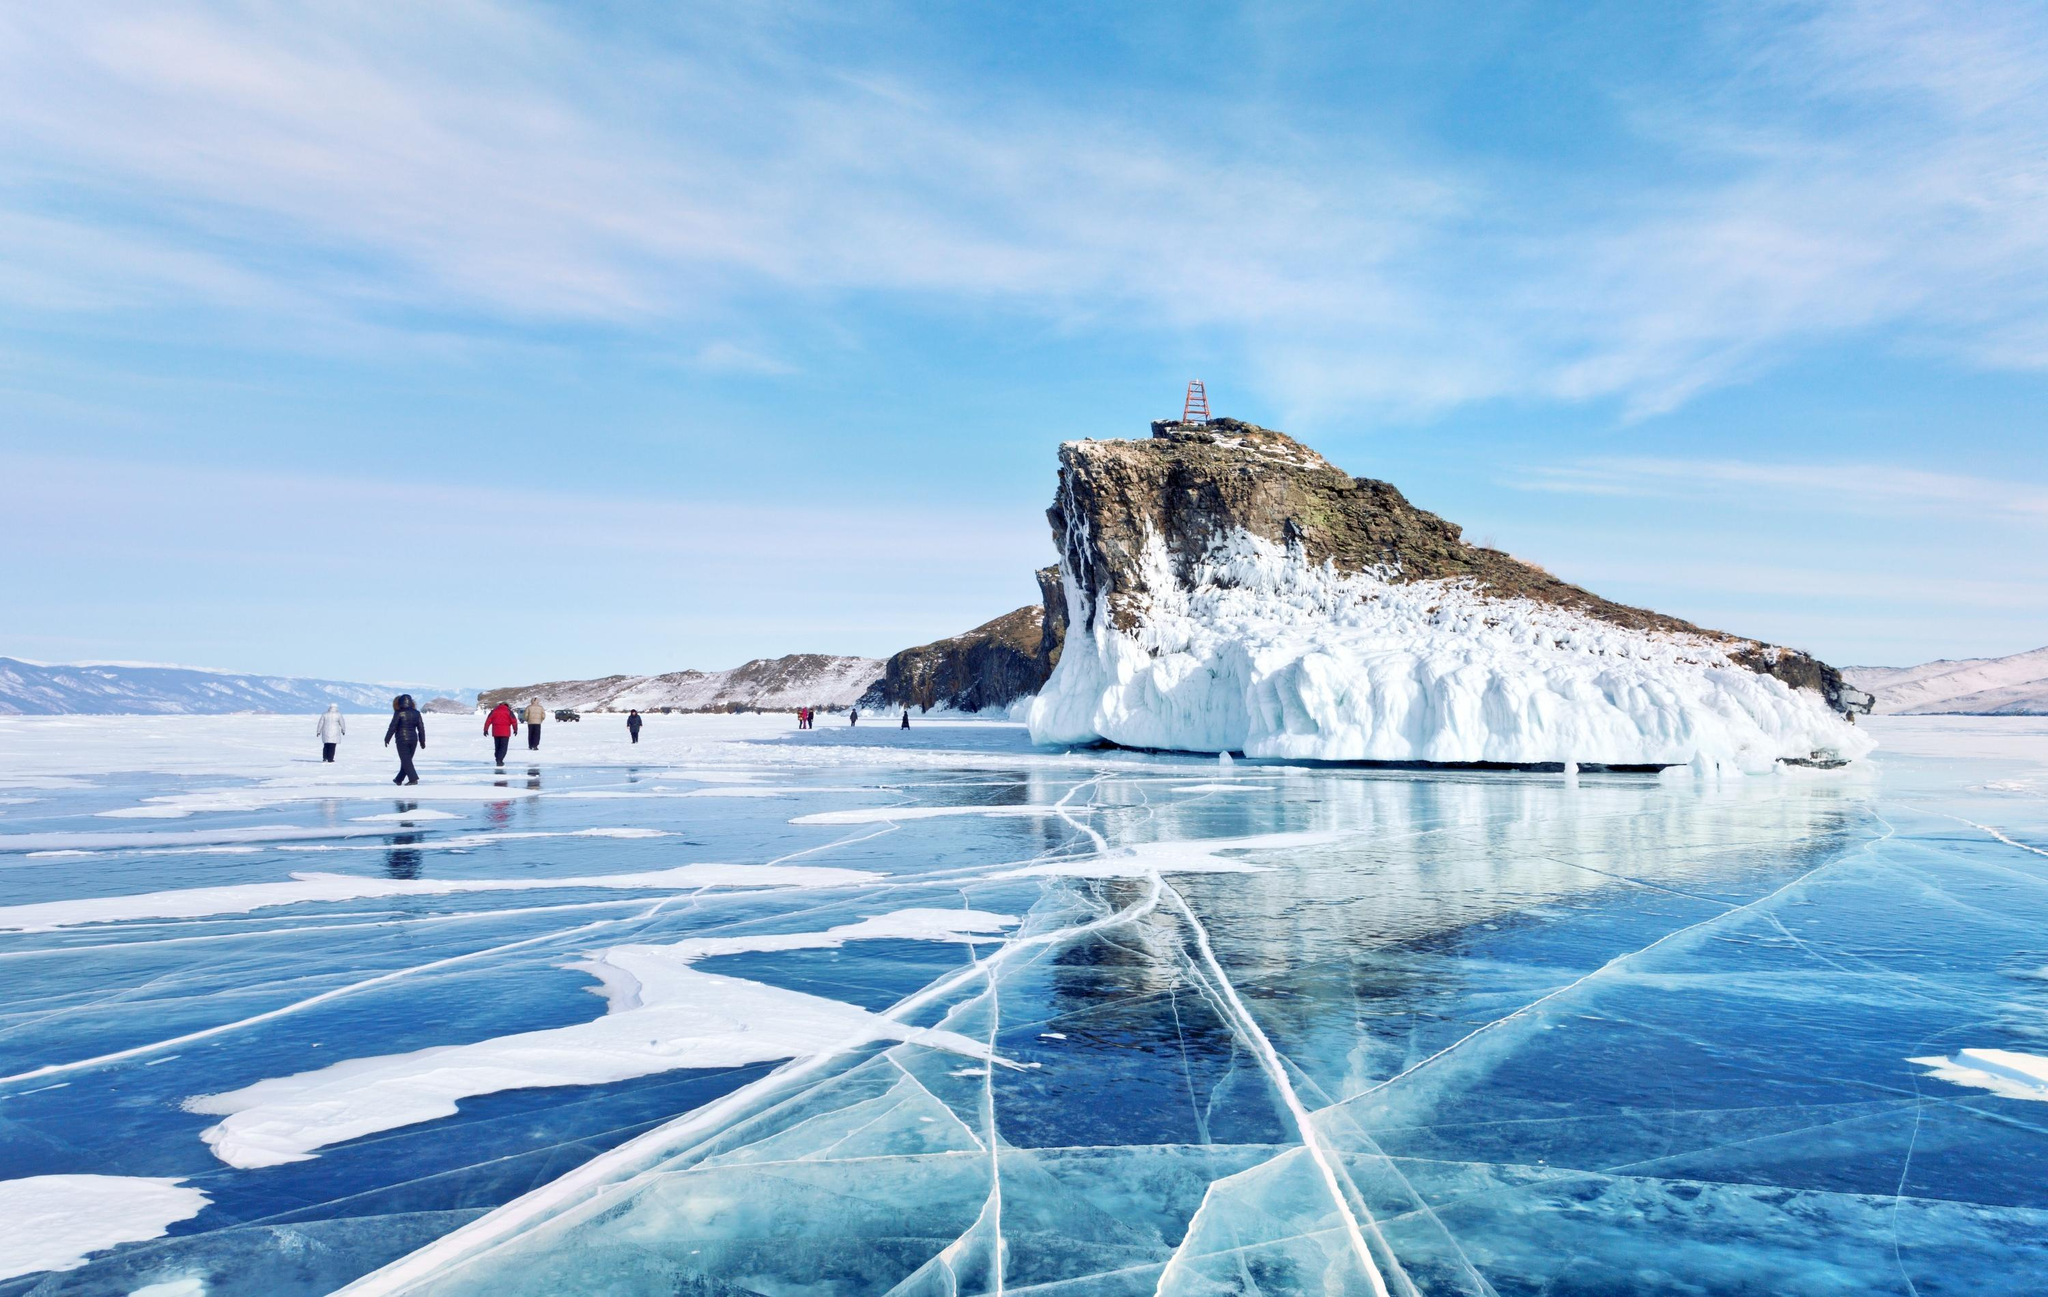What do you think is going on in this snapshot? This image shows Lake Baikal during winter, the deepest and oldest freshwater lake in the world, located in Siberia, Russia. The photograph captures several people adventuring across the vast, transparent ice that reflects the sky's blue tones, marked with intricate patterns of deep cracks and bubbles trapped beneath the surface. They appear to be tourists, likely drawn by the famous phenomenon of the crystal-clear ice and the unique experience of walking on it. The rocky island in the foreground, capped with a modest lighthouse, is a popular destination for such visitors. The island, with its sheer snow-drifted cliffs shows evidence of harsh, windy conditions, yet it stands as a beacon, symbolizing the rugged beauty and resilience of the Siberian landscape. This scene beautifully juxtaposes the human element against the expansive, untouched natural environment. 